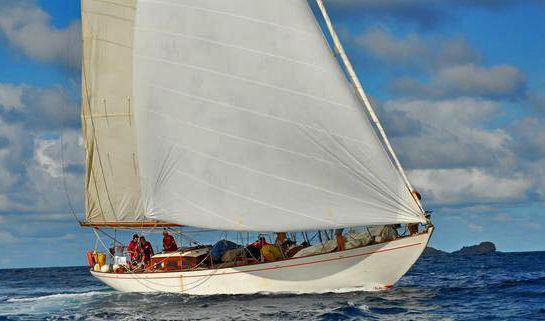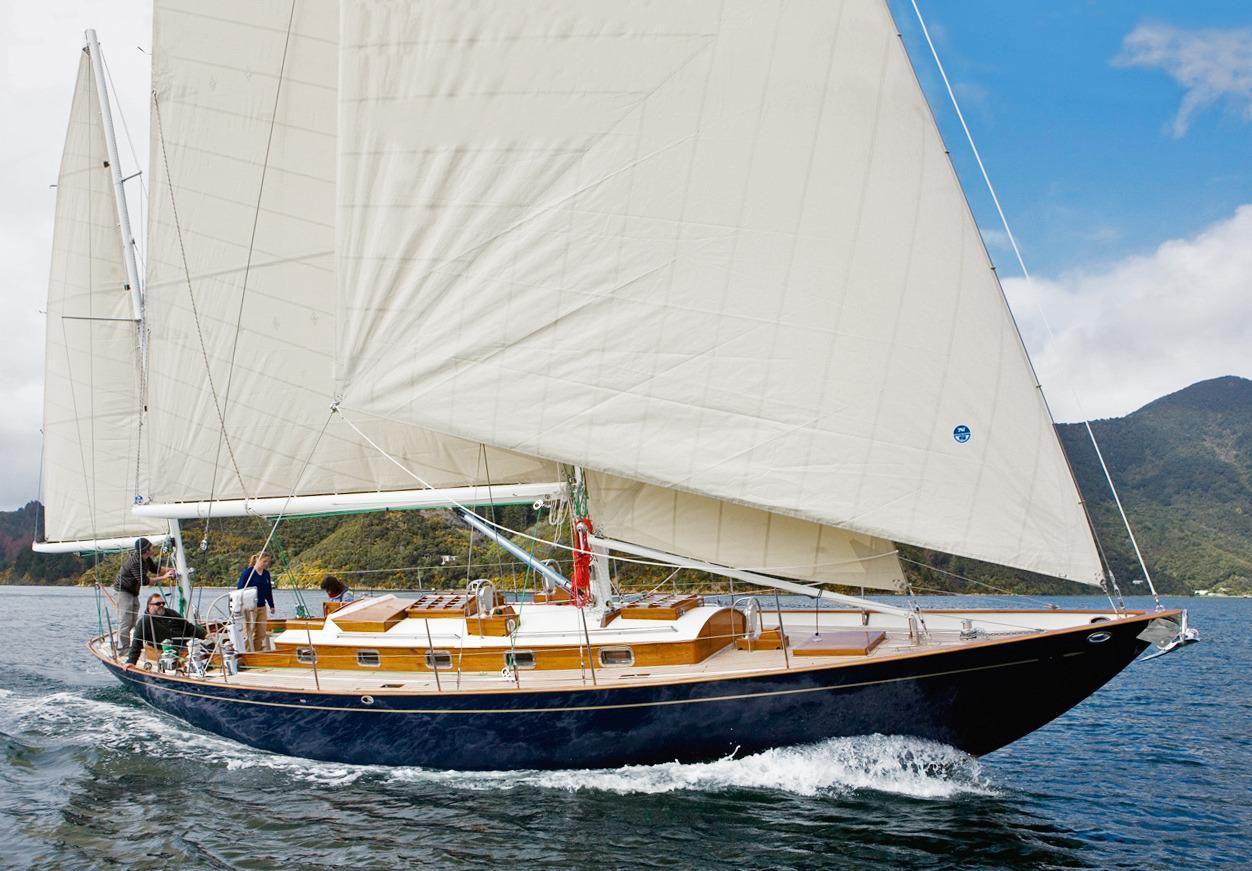The first image is the image on the left, the second image is the image on the right. Examine the images to the left and right. Is the description "An image shows a sailboat with a blue body creating white spray as it moves across the water." accurate? Answer yes or no. Yes. 